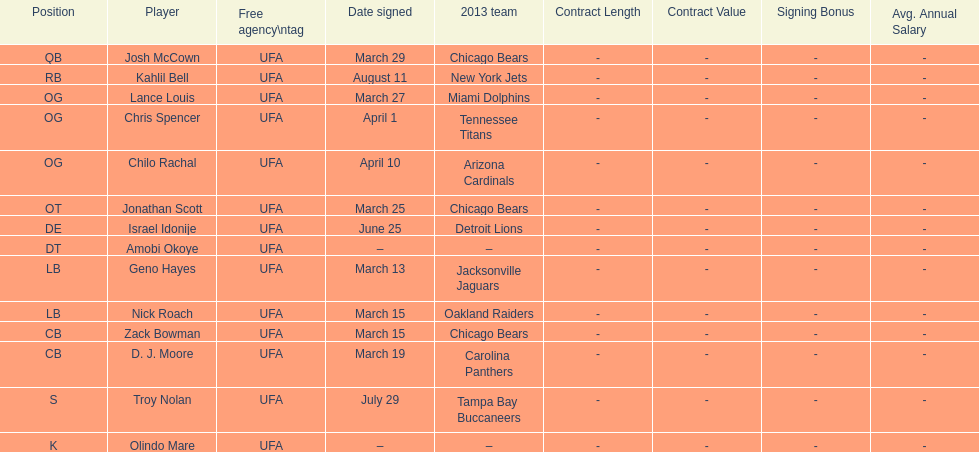How many players signed up in march? 7. 